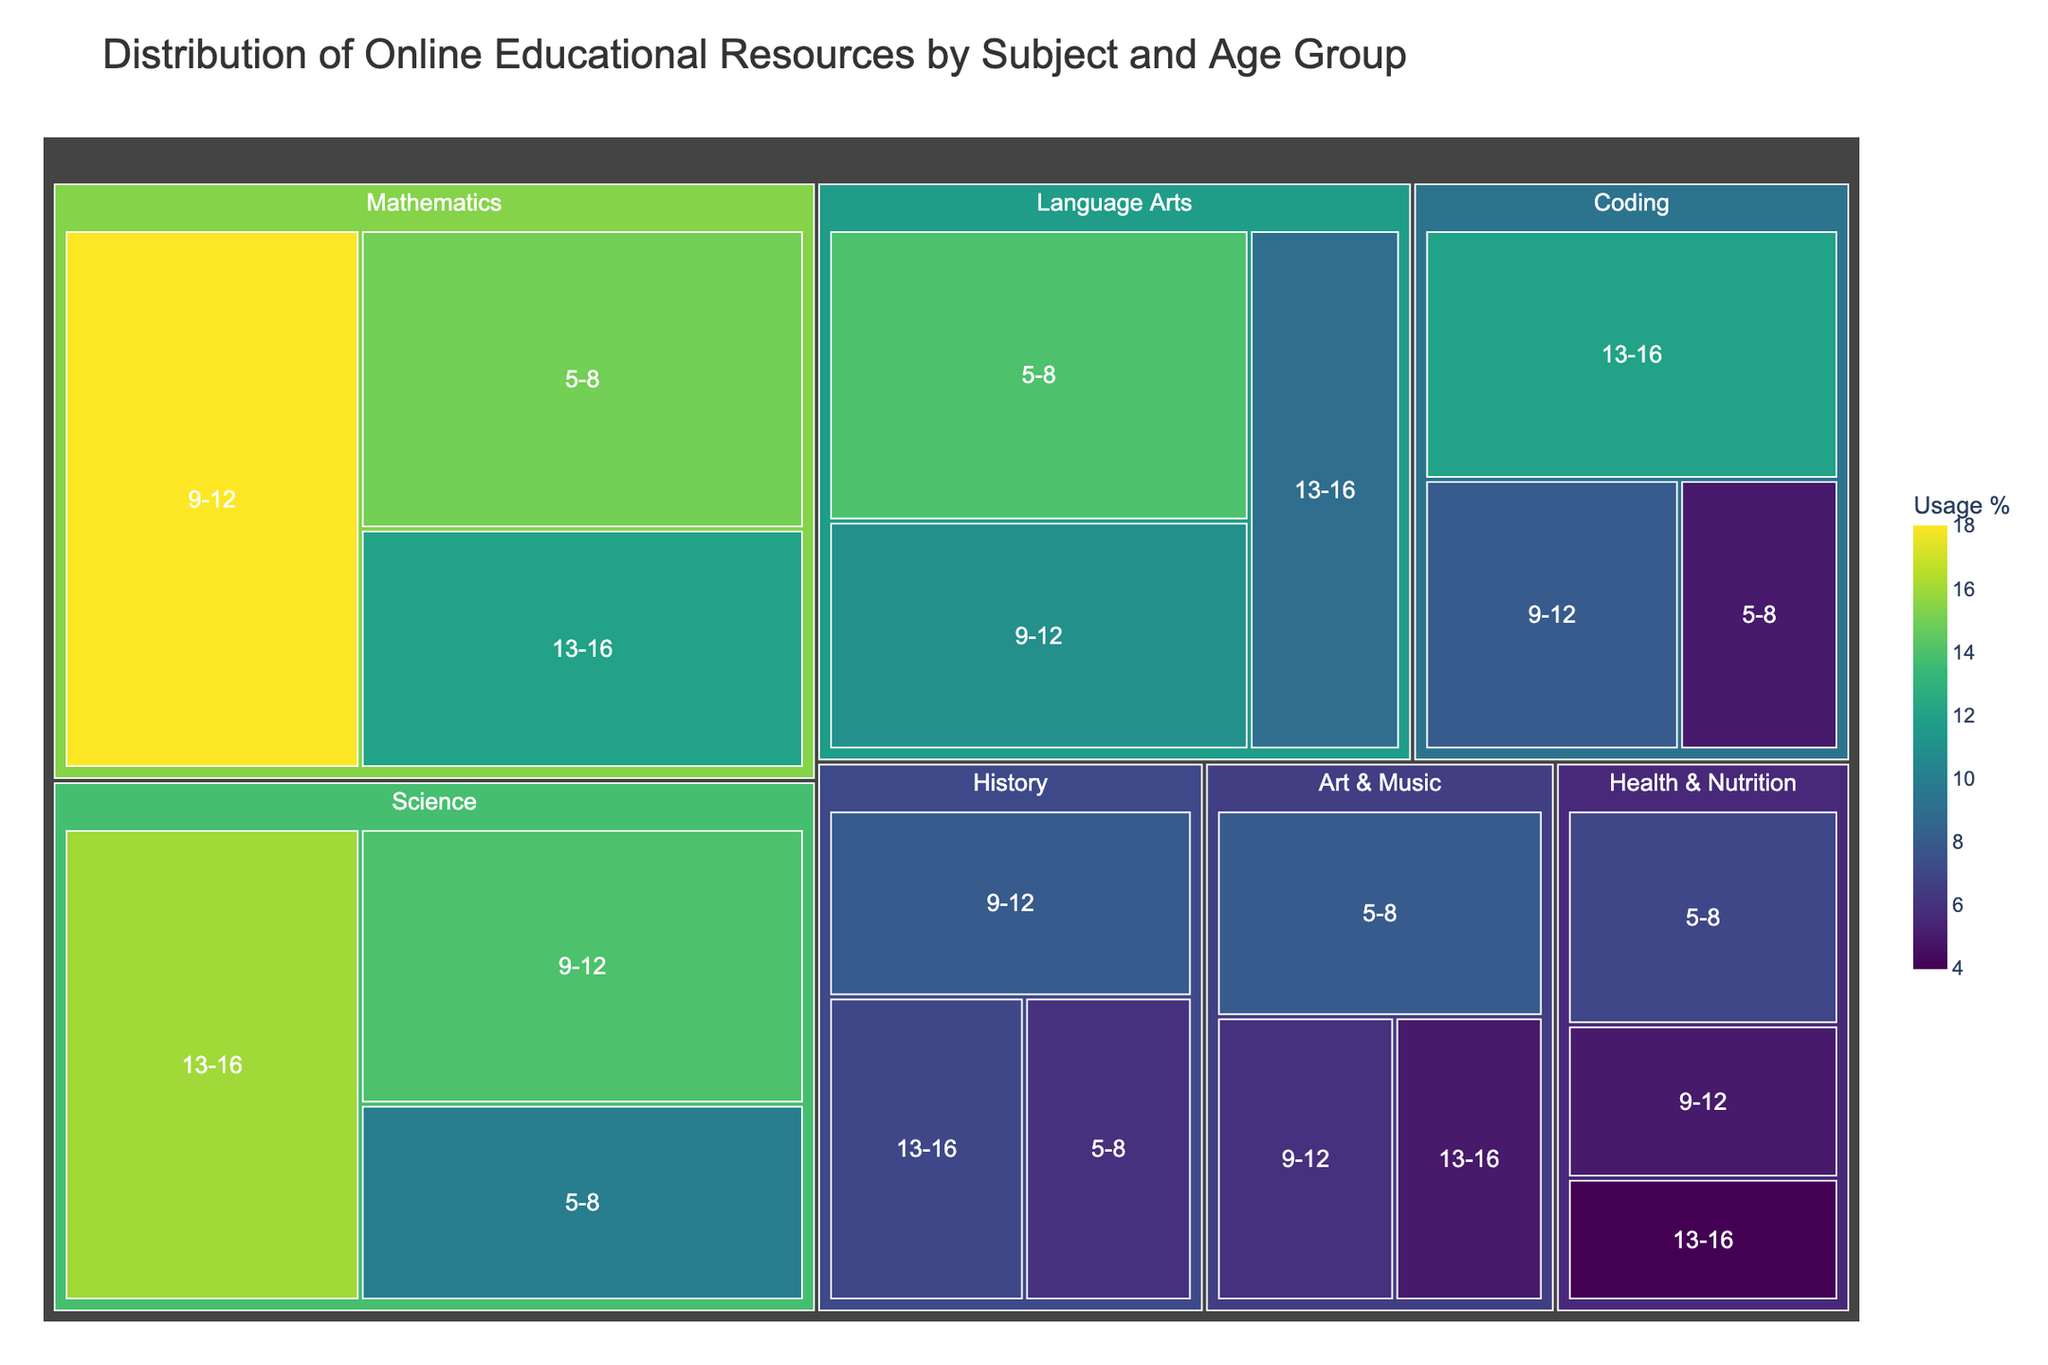what is the title of the figure? The title is typically found at the top of the figure in a larger font size. It summarizes what the figure represents. Here the title of the figure is "Distribution of Online Educational Resources by Subject and Age Group".
Answer: Distribution of Online Educational Resources by Subject and Age Group which subject has the highest usage percentage for age group 9-12? By examining the different segments for the age group 9-12, we see that the "Mathematics" section has the highest usage percentage at 18%.
Answer: Mathematics calculate the total usage percentage for the subjects Mathematics and Science across all age groups To calculate this, sum up the percentages for Mathematics (15 + 18 + 12) and Science (10 + 14 + 16). Mathematically, (15 + 18 + 12) + (10 + 14 + 16) = 45 + 40 = 85.
Answer: 85 is the usage percentage for Coding higher for the age group 13-16 than for 5-8? By examining the usage percentage for Coding in the age groups 5-8 and 13-16, we see 5% for 5-8 and 12% for 13-16, thus the percentage is higher for the 13-16 age group.
Answer: Yes which age group has the least interest in Health & Nutrition? By comparing the usage percentages across the age groups for Health & Nutrition, we see 7% for age group 5-8, 5% for 9-12, and 4% for 13-16. Hence, age group 13-16 shows the least interest.
Answer: 13-16 compare the interest in Art & Music between the age groups 5-8 and 9-12. For the age group 5-8, Art & Music has a usage percentage of 8%, while for 9-12 it is 6%. Therefore, the interest is higher in the 5-8 age group.
Answer: 5-8 identify the subject with the smallest usage percentage across all age groups By examining all the segments, the smallest usage percentage is shown in Health & Nutrition for the 13-16 age group with 4%.
Answer: Health & Nutrition find the combined usage percentage of Language Arts for age groups 5-8 and 13-16. Summing up the usage percentages of Language Arts for the age groups 5-8 (14%) and 13-16 (9%), we get 14 + 9 = 23%.
Answer: 23 what color represents the highest usage percentage in the treemap? In the treemap, usage percentage is represented by a color gradient. The highest usage percentage is 18% (Mathematics, 9-12), which corresponds to the darkest color in the Viridis scale.
Answer: Dark Green which age group is most engaged with Science? By comparing the usage percentages of Science across all age groups, the age group 13-16 has the highest engagement at 16%.
Answer: 13-16 